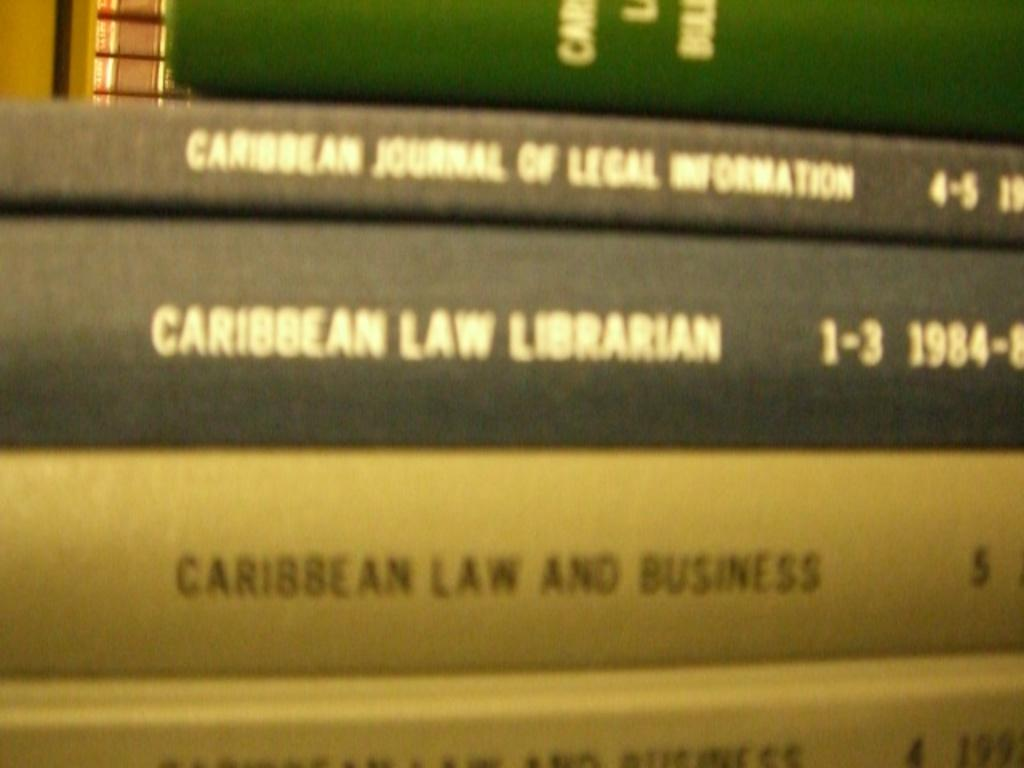<image>
Create a compact narrative representing the image presented. A stack of books including the Caribbean Law Librarian. 